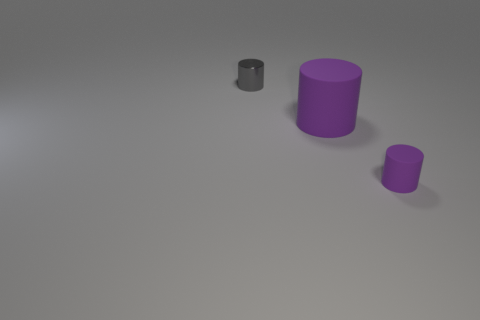Subtract all green cylinders. Subtract all yellow spheres. How many cylinders are left? 3 Add 3 big cylinders. How many objects exist? 6 Add 2 small shiny cylinders. How many small shiny cylinders are left? 3 Add 2 tiny objects. How many tiny objects exist? 4 Subtract 0 yellow cubes. How many objects are left? 3 Subtract all small objects. Subtract all gray things. How many objects are left? 0 